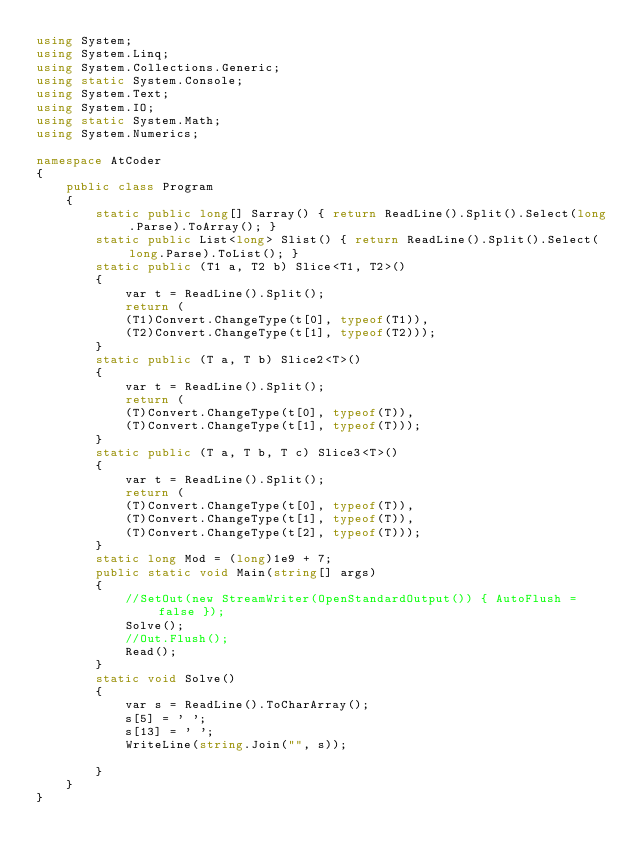<code> <loc_0><loc_0><loc_500><loc_500><_C#_>using System;
using System.Linq;
using System.Collections.Generic;
using static System.Console;
using System.Text;
using System.IO;
using static System.Math;
using System.Numerics;

namespace AtCoder
{
    public class Program
    {
        static public long[] Sarray() { return ReadLine().Split().Select(long.Parse).ToArray(); }
        static public List<long> Slist() { return ReadLine().Split().Select(long.Parse).ToList(); }
        static public (T1 a, T2 b) Slice<T1, T2>()
        {
            var t = ReadLine().Split();
            return (
            (T1)Convert.ChangeType(t[0], typeof(T1)),
            (T2)Convert.ChangeType(t[1], typeof(T2)));
        }
        static public (T a, T b) Slice2<T>()
        {
            var t = ReadLine().Split();
            return (
            (T)Convert.ChangeType(t[0], typeof(T)),
            (T)Convert.ChangeType(t[1], typeof(T)));
        }
        static public (T a, T b, T c) Slice3<T>()
        {
            var t = ReadLine().Split();
            return (
            (T)Convert.ChangeType(t[0], typeof(T)),
            (T)Convert.ChangeType(t[1], typeof(T)),
            (T)Convert.ChangeType(t[2], typeof(T)));
        }
        static long Mod = (long)1e9 + 7;
        public static void Main(string[] args)
        {
            //SetOut(new StreamWriter(OpenStandardOutput()) { AutoFlush = false });
            Solve();
            //Out.Flush();
            Read();
        }
        static void Solve()
        {
            var s = ReadLine().ToCharArray();
            s[5] = ' ';
            s[13] = ' ';
            WriteLine(string.Join("", s));
            
        }
    }
}</code> 